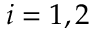<formula> <loc_0><loc_0><loc_500><loc_500>i = 1 , 2</formula> 